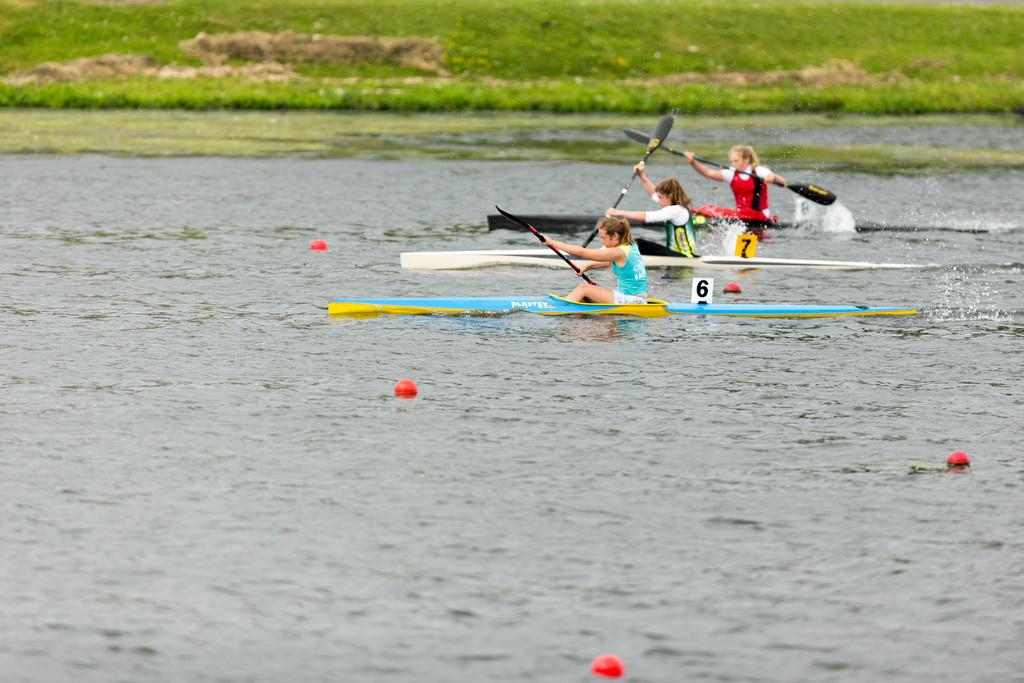What type of surface is at the top of the image? There is grass at the top of the image. What are the people doing in the image? People are sitting on boats in the water. What are the people holding while on the boats? The people are holding paddles. What can be seen on the boats besides the people and paddles? There are number boards on the boats. What type of bone can be seen on the floor in the image? There is no bone or floor present in the image; it features grass, boats, and water. 